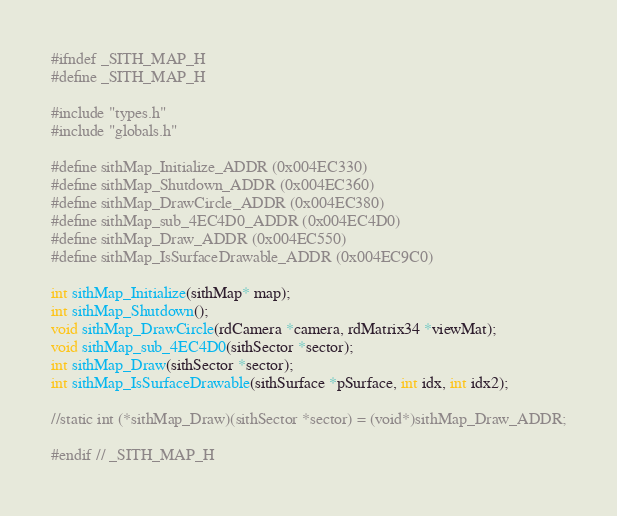<code> <loc_0><loc_0><loc_500><loc_500><_C_>#ifndef _SITH_MAP_H
#define _SITH_MAP_H

#include "types.h"
#include "globals.h"

#define sithMap_Initialize_ADDR (0x004EC330)
#define sithMap_Shutdown_ADDR (0x004EC360)
#define sithMap_DrawCircle_ADDR (0x004EC380)
#define sithMap_sub_4EC4D0_ADDR (0x004EC4D0)
#define sithMap_Draw_ADDR (0x004EC550)
#define sithMap_IsSurfaceDrawable_ADDR (0x004EC9C0)

int sithMap_Initialize(sithMap* map);
int sithMap_Shutdown();
void sithMap_DrawCircle(rdCamera *camera, rdMatrix34 *viewMat);
void sithMap_sub_4EC4D0(sithSector *sector);
int sithMap_Draw(sithSector *sector);
int sithMap_IsSurfaceDrawable(sithSurface *pSurface, int idx, int idx2);

//static int (*sithMap_Draw)(sithSector *sector) = (void*)sithMap_Draw_ADDR;

#endif // _SITH_MAP_H
</code> 